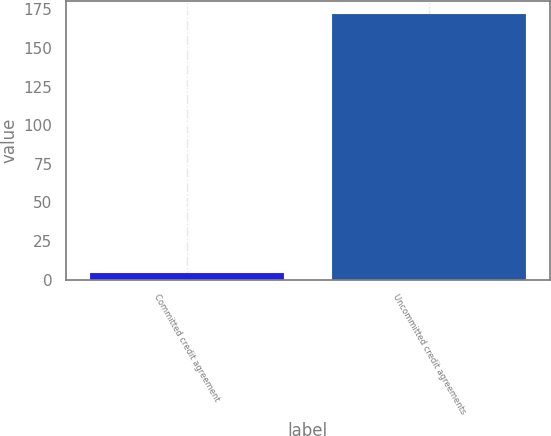Convert chart to OTSL. <chart><loc_0><loc_0><loc_500><loc_500><bar_chart><fcel>Committed credit agreement<fcel>Uncommitted credit agreements<nl><fcel>4.29<fcel>172.1<nl></chart> 